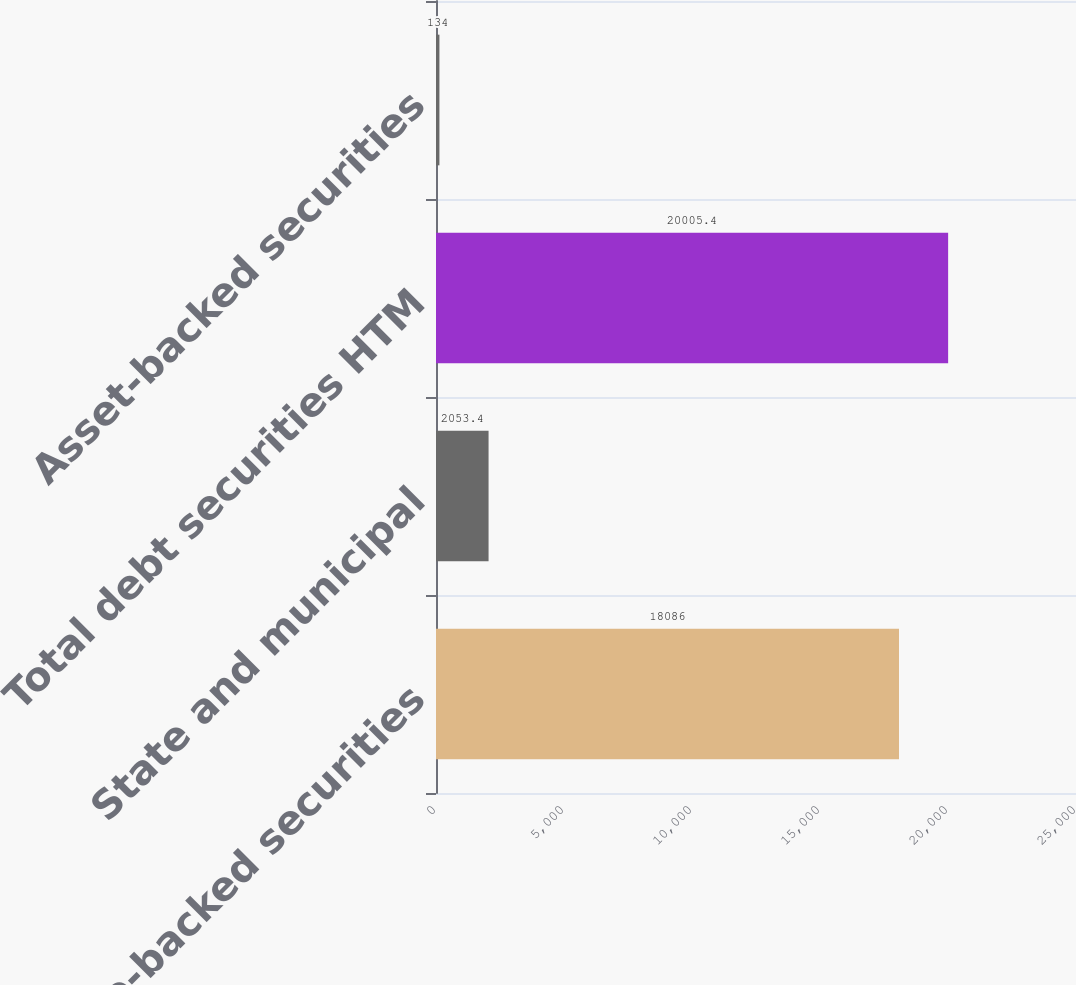Convert chart to OTSL. <chart><loc_0><loc_0><loc_500><loc_500><bar_chart><fcel>Mortgage-backed securities<fcel>State and municipal<fcel>Total debt securities HTM<fcel>Asset-backed securities<nl><fcel>18086<fcel>2053.4<fcel>20005.4<fcel>134<nl></chart> 